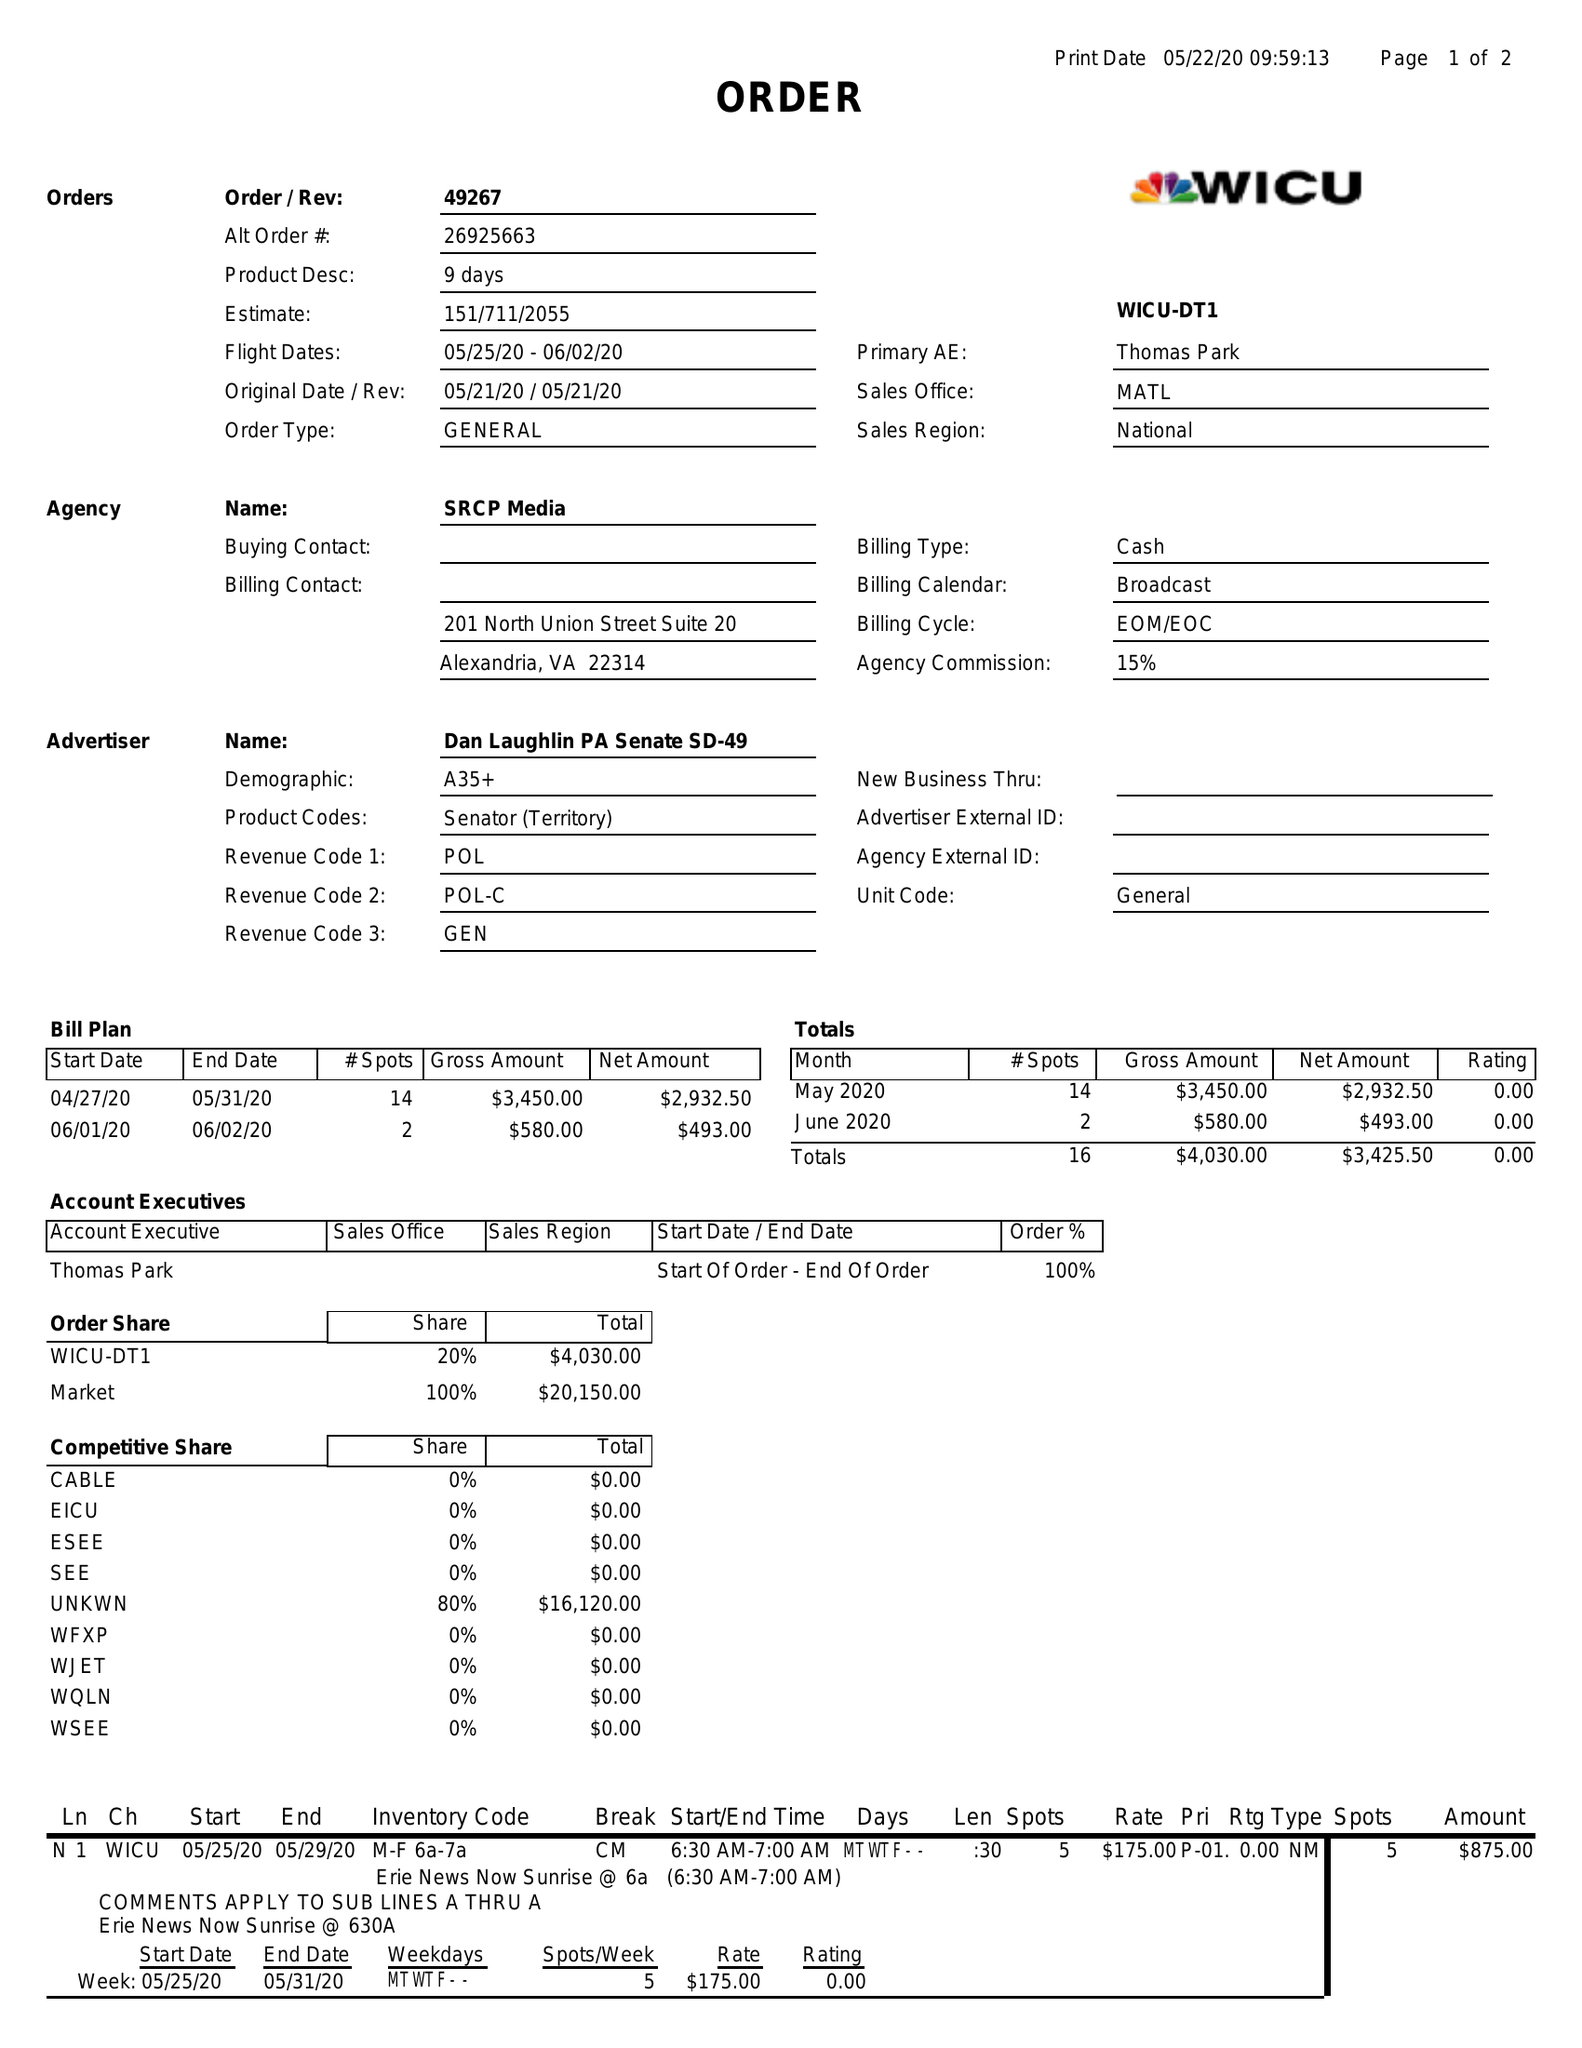What is the value for the flight_to?
Answer the question using a single word or phrase. 06/02/20 